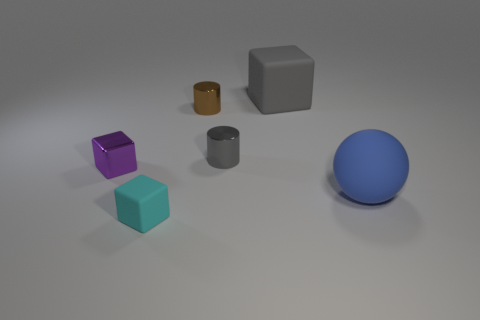There is a shiny thing on the left side of the brown cylinder; does it have the same shape as the metal thing that is behind the gray metallic object?
Provide a succinct answer. No. Is there a tiny red thing made of the same material as the large cube?
Your answer should be very brief. No. There is a large object that is on the right side of the big matte thing on the left side of the big object in front of the big gray thing; what is its color?
Your answer should be very brief. Blue. Is the small thing in front of the rubber ball made of the same material as the small block behind the cyan block?
Provide a succinct answer. No. What is the shape of the rubber thing that is in front of the blue ball?
Provide a succinct answer. Cube. How many objects are big red matte spheres or gray metal cylinders that are behind the large blue ball?
Provide a short and direct response. 1. Is the material of the tiny purple block the same as the tiny brown thing?
Ensure brevity in your answer.  Yes. Are there an equal number of tiny metallic blocks to the right of the big block and gray cylinders on the left side of the cyan cube?
Your response must be concise. Yes. There is a small cyan matte object; how many small metal things are to the left of it?
Your answer should be very brief. 1. What number of things are either big green metallic things or tiny purple shiny blocks?
Your answer should be very brief. 1. 